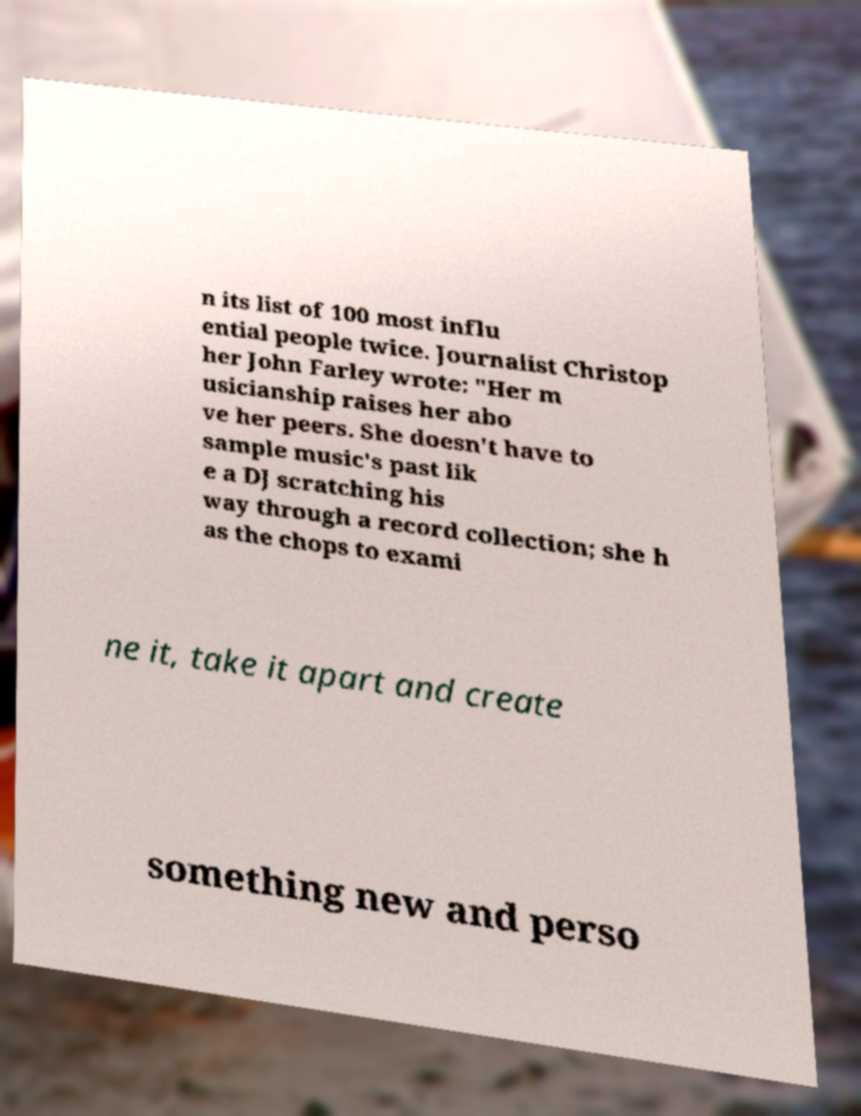Please identify and transcribe the text found in this image. n its list of 100 most influ ential people twice. Journalist Christop her John Farley wrote: "Her m usicianship raises her abo ve her peers. She doesn't have to sample music's past lik e a DJ scratching his way through a record collection; she h as the chops to exami ne it, take it apart and create something new and perso 